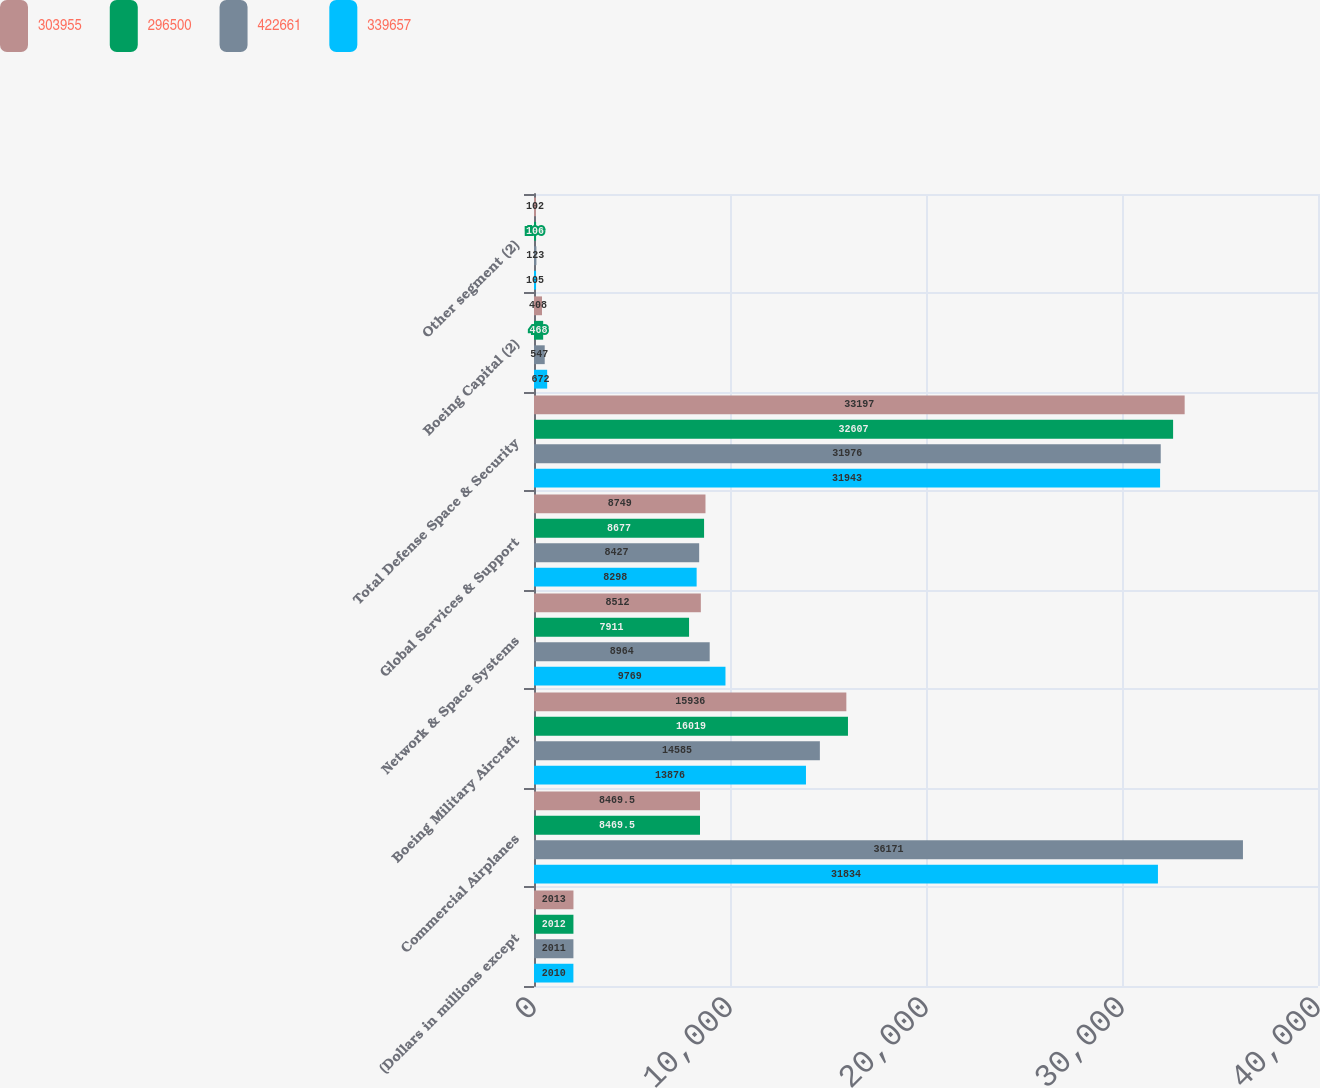<chart> <loc_0><loc_0><loc_500><loc_500><stacked_bar_chart><ecel><fcel>(Dollars in millions except<fcel>Commercial Airplanes<fcel>Boeing Military Aircraft<fcel>Network & Space Systems<fcel>Global Services & Support<fcel>Total Defense Space & Security<fcel>Boeing Capital (2)<fcel>Other segment (2)<nl><fcel>303955<fcel>2013<fcel>8469.5<fcel>15936<fcel>8512<fcel>8749<fcel>33197<fcel>408<fcel>102<nl><fcel>296500<fcel>2012<fcel>8469.5<fcel>16019<fcel>7911<fcel>8677<fcel>32607<fcel>468<fcel>106<nl><fcel>422661<fcel>2011<fcel>36171<fcel>14585<fcel>8964<fcel>8427<fcel>31976<fcel>547<fcel>123<nl><fcel>339657<fcel>2010<fcel>31834<fcel>13876<fcel>9769<fcel>8298<fcel>31943<fcel>672<fcel>105<nl></chart> 